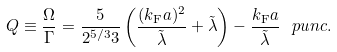Convert formula to latex. <formula><loc_0><loc_0><loc_500><loc_500>Q \equiv \frac { \Omega } { \Gamma } = \frac { 5 } { 2 ^ { 5 / 3 } 3 } \left ( \frac { ( k _ { \text {F} } a ) ^ { 2 } } { \tilde { \lambda } } + \tilde { \lambda } \right ) - \frac { k _ { \text {F} } a } { \tilde { \lambda } } \ p u n c { . }</formula> 